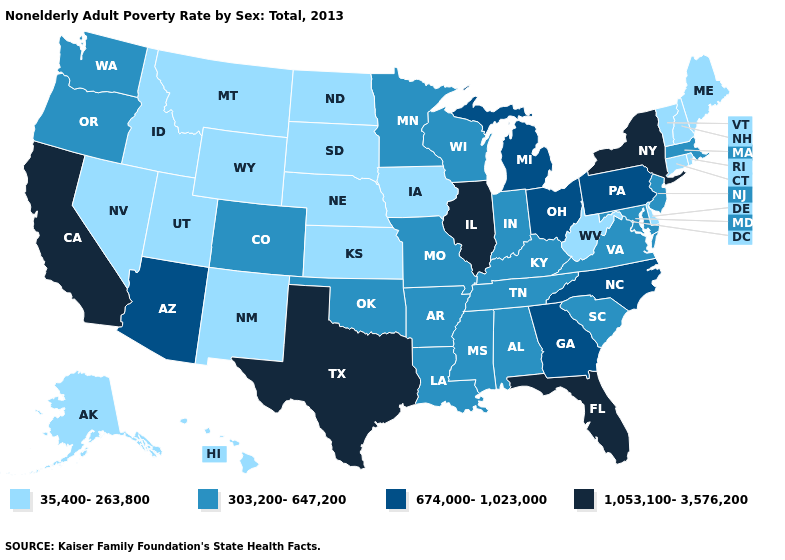What is the value of New Hampshire?
Concise answer only. 35,400-263,800. Name the states that have a value in the range 1,053,100-3,576,200?
Short answer required. California, Florida, Illinois, New York, Texas. Name the states that have a value in the range 1,053,100-3,576,200?
Answer briefly. California, Florida, Illinois, New York, Texas. Name the states that have a value in the range 674,000-1,023,000?
Short answer required. Arizona, Georgia, Michigan, North Carolina, Ohio, Pennsylvania. What is the highest value in states that border Nevada?
Keep it brief. 1,053,100-3,576,200. What is the lowest value in the South?
Concise answer only. 35,400-263,800. What is the value of Louisiana?
Concise answer only. 303,200-647,200. Does Nebraska have a higher value than Minnesota?
Short answer required. No. How many symbols are there in the legend?
Short answer required. 4. Among the states that border Minnesota , which have the lowest value?
Be succinct. Iowa, North Dakota, South Dakota. Does Mississippi have the same value as North Carolina?
Write a very short answer. No. What is the highest value in the MidWest ?
Short answer required. 1,053,100-3,576,200. Among the states that border New Hampshire , does Maine have the lowest value?
Give a very brief answer. Yes. Does Alaska have the highest value in the West?
Quick response, please. No. What is the value of Illinois?
Concise answer only. 1,053,100-3,576,200. 